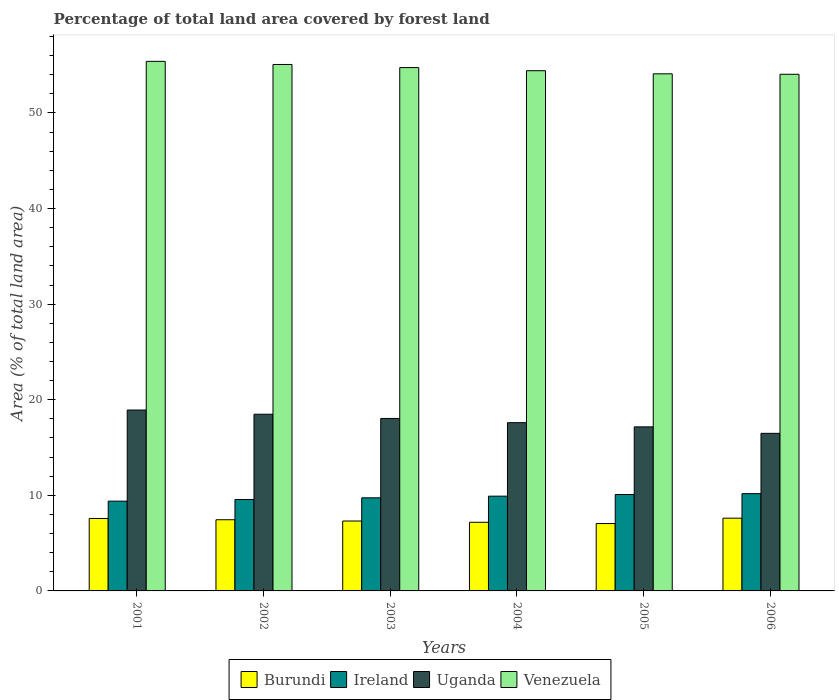Are the number of bars per tick equal to the number of legend labels?
Give a very brief answer. Yes. What is the label of the 5th group of bars from the left?
Ensure brevity in your answer.  2005. In how many cases, is the number of bars for a given year not equal to the number of legend labels?
Your answer should be compact. 0. What is the percentage of forest land in Burundi in 2003?
Ensure brevity in your answer.  7.31. Across all years, what is the maximum percentage of forest land in Venezuela?
Provide a short and direct response. 55.4. Across all years, what is the minimum percentage of forest land in Ireland?
Offer a terse response. 9.39. In which year was the percentage of forest land in Venezuela maximum?
Make the answer very short. 2001. In which year was the percentage of forest land in Venezuela minimum?
Your response must be concise. 2006. What is the total percentage of forest land in Ireland in the graph?
Your answer should be compact. 58.87. What is the difference between the percentage of forest land in Burundi in 2005 and that in 2006?
Your response must be concise. -0.56. What is the difference between the percentage of forest land in Ireland in 2003 and the percentage of forest land in Uganda in 2002?
Make the answer very short. -8.74. What is the average percentage of forest land in Burundi per year?
Offer a very short reply. 7.36. In the year 2001, what is the difference between the percentage of forest land in Venezuela and percentage of forest land in Ireland?
Your response must be concise. 46.01. What is the ratio of the percentage of forest land in Ireland in 2001 to that in 2002?
Provide a short and direct response. 0.98. What is the difference between the highest and the second highest percentage of forest land in Ireland?
Provide a short and direct response. 0.09. What is the difference between the highest and the lowest percentage of forest land in Uganda?
Provide a succinct answer. 2.44. In how many years, is the percentage of forest land in Burundi greater than the average percentage of forest land in Burundi taken over all years?
Offer a very short reply. 3. Is the sum of the percentage of forest land in Uganda in 2001 and 2002 greater than the maximum percentage of forest land in Burundi across all years?
Provide a succinct answer. Yes. What does the 4th bar from the left in 2006 represents?
Your answer should be very brief. Venezuela. What does the 4th bar from the right in 2005 represents?
Give a very brief answer. Burundi. Are all the bars in the graph horizontal?
Make the answer very short. No. Does the graph contain any zero values?
Provide a short and direct response. No. Does the graph contain grids?
Keep it short and to the point. No. Where does the legend appear in the graph?
Ensure brevity in your answer.  Bottom center. How are the legend labels stacked?
Ensure brevity in your answer.  Horizontal. What is the title of the graph?
Make the answer very short. Percentage of total land area covered by forest land. What is the label or title of the Y-axis?
Offer a terse response. Area (% of total land area). What is the Area (% of total land area) in Burundi in 2001?
Your response must be concise. 7.58. What is the Area (% of total land area) in Ireland in 2001?
Provide a short and direct response. 9.39. What is the Area (% of total land area) of Uganda in 2001?
Provide a succinct answer. 18.92. What is the Area (% of total land area) of Venezuela in 2001?
Give a very brief answer. 55.4. What is the Area (% of total land area) of Burundi in 2002?
Your response must be concise. 7.45. What is the Area (% of total land area) of Ireland in 2002?
Ensure brevity in your answer.  9.56. What is the Area (% of total land area) of Uganda in 2002?
Offer a terse response. 18.48. What is the Area (% of total land area) of Venezuela in 2002?
Offer a very short reply. 55.07. What is the Area (% of total land area) in Burundi in 2003?
Offer a terse response. 7.31. What is the Area (% of total land area) in Ireland in 2003?
Provide a succinct answer. 9.74. What is the Area (% of total land area) of Uganda in 2003?
Your response must be concise. 18.04. What is the Area (% of total land area) of Venezuela in 2003?
Provide a short and direct response. 54.75. What is the Area (% of total land area) of Burundi in 2004?
Your answer should be very brief. 7.18. What is the Area (% of total land area) of Ireland in 2004?
Offer a very short reply. 9.91. What is the Area (% of total land area) in Uganda in 2004?
Your response must be concise. 17.6. What is the Area (% of total land area) in Venezuela in 2004?
Offer a very short reply. 54.42. What is the Area (% of total land area) in Burundi in 2005?
Your response must be concise. 7.05. What is the Area (% of total land area) in Ireland in 2005?
Provide a short and direct response. 10.09. What is the Area (% of total land area) in Uganda in 2005?
Your answer should be compact. 17.16. What is the Area (% of total land area) of Venezuela in 2005?
Give a very brief answer. 54.09. What is the Area (% of total land area) in Burundi in 2006?
Offer a terse response. 7.61. What is the Area (% of total land area) of Ireland in 2006?
Give a very brief answer. 10.18. What is the Area (% of total land area) in Uganda in 2006?
Ensure brevity in your answer.  16.48. What is the Area (% of total land area) in Venezuela in 2006?
Provide a short and direct response. 54.05. Across all years, what is the maximum Area (% of total land area) of Burundi?
Keep it short and to the point. 7.61. Across all years, what is the maximum Area (% of total land area) of Ireland?
Offer a very short reply. 10.18. Across all years, what is the maximum Area (% of total land area) of Uganda?
Offer a terse response. 18.92. Across all years, what is the maximum Area (% of total land area) of Venezuela?
Provide a succinct answer. 55.4. Across all years, what is the minimum Area (% of total land area) of Burundi?
Provide a short and direct response. 7.05. Across all years, what is the minimum Area (% of total land area) in Ireland?
Keep it short and to the point. 9.39. Across all years, what is the minimum Area (% of total land area) of Uganda?
Provide a succinct answer. 16.48. Across all years, what is the minimum Area (% of total land area) of Venezuela?
Offer a terse response. 54.05. What is the total Area (% of total land area) in Burundi in the graph?
Your answer should be very brief. 44.17. What is the total Area (% of total land area) in Ireland in the graph?
Offer a terse response. 58.87. What is the total Area (% of total land area) in Uganda in the graph?
Make the answer very short. 106.7. What is the total Area (% of total land area) of Venezuela in the graph?
Make the answer very short. 327.77. What is the difference between the Area (% of total land area) in Burundi in 2001 and that in 2002?
Give a very brief answer. 0.13. What is the difference between the Area (% of total land area) of Ireland in 2001 and that in 2002?
Offer a very short reply. -0.17. What is the difference between the Area (% of total land area) of Uganda in 2001 and that in 2002?
Your answer should be compact. 0.44. What is the difference between the Area (% of total land area) of Venezuela in 2001 and that in 2002?
Ensure brevity in your answer.  0.33. What is the difference between the Area (% of total land area) in Burundi in 2001 and that in 2003?
Your answer should be very brief. 0.26. What is the difference between the Area (% of total land area) of Ireland in 2001 and that in 2003?
Provide a succinct answer. -0.35. What is the difference between the Area (% of total land area) of Uganda in 2001 and that in 2003?
Offer a terse response. 0.88. What is the difference between the Area (% of total land area) in Venezuela in 2001 and that in 2003?
Offer a very short reply. 0.65. What is the difference between the Area (% of total land area) of Burundi in 2001 and that in 2004?
Make the answer very short. 0.4. What is the difference between the Area (% of total land area) of Ireland in 2001 and that in 2004?
Provide a succinct answer. -0.52. What is the difference between the Area (% of total land area) in Uganda in 2001 and that in 2004?
Make the answer very short. 1.32. What is the difference between the Area (% of total land area) of Venezuela in 2001 and that in 2004?
Your response must be concise. 0.98. What is the difference between the Area (% of total land area) in Burundi in 2001 and that in 2005?
Make the answer very short. 0.53. What is the difference between the Area (% of total land area) in Ireland in 2001 and that in 2005?
Give a very brief answer. -0.7. What is the difference between the Area (% of total land area) in Uganda in 2001 and that in 2005?
Make the answer very short. 1.76. What is the difference between the Area (% of total land area) in Venezuela in 2001 and that in 2005?
Provide a succinct answer. 1.3. What is the difference between the Area (% of total land area) of Burundi in 2001 and that in 2006?
Offer a terse response. -0.03. What is the difference between the Area (% of total land area) in Ireland in 2001 and that in 2006?
Keep it short and to the point. -0.78. What is the difference between the Area (% of total land area) in Uganda in 2001 and that in 2006?
Make the answer very short. 2.44. What is the difference between the Area (% of total land area) in Venezuela in 2001 and that in 2006?
Give a very brief answer. 1.35. What is the difference between the Area (% of total land area) of Burundi in 2002 and that in 2003?
Keep it short and to the point. 0.13. What is the difference between the Area (% of total land area) in Ireland in 2002 and that in 2003?
Give a very brief answer. -0.17. What is the difference between the Area (% of total land area) in Uganda in 2002 and that in 2003?
Your response must be concise. 0.44. What is the difference between the Area (% of total land area) of Venezuela in 2002 and that in 2003?
Give a very brief answer. 0.33. What is the difference between the Area (% of total land area) of Burundi in 2002 and that in 2004?
Provide a succinct answer. 0.26. What is the difference between the Area (% of total land area) in Ireland in 2002 and that in 2004?
Ensure brevity in your answer.  -0.35. What is the difference between the Area (% of total land area) of Uganda in 2002 and that in 2004?
Ensure brevity in your answer.  0.88. What is the difference between the Area (% of total land area) in Venezuela in 2002 and that in 2004?
Provide a succinct answer. 0.65. What is the difference between the Area (% of total land area) of Burundi in 2002 and that in 2005?
Your answer should be very brief. 0.4. What is the difference between the Area (% of total land area) of Ireland in 2002 and that in 2005?
Offer a very short reply. -0.52. What is the difference between the Area (% of total land area) of Uganda in 2002 and that in 2005?
Ensure brevity in your answer.  1.32. What is the difference between the Area (% of total land area) of Venezuela in 2002 and that in 2005?
Provide a short and direct response. 0.98. What is the difference between the Area (% of total land area) in Burundi in 2002 and that in 2006?
Ensure brevity in your answer.  -0.16. What is the difference between the Area (% of total land area) in Ireland in 2002 and that in 2006?
Provide a succinct answer. -0.61. What is the difference between the Area (% of total land area) in Uganda in 2002 and that in 2006?
Your answer should be very brief. 2. What is the difference between the Area (% of total land area) in Venezuela in 2002 and that in 2006?
Make the answer very short. 1.03. What is the difference between the Area (% of total land area) of Burundi in 2003 and that in 2004?
Provide a succinct answer. 0.13. What is the difference between the Area (% of total land area) of Ireland in 2003 and that in 2004?
Offer a very short reply. -0.17. What is the difference between the Area (% of total land area) of Uganda in 2003 and that in 2004?
Offer a terse response. 0.44. What is the difference between the Area (% of total land area) of Venezuela in 2003 and that in 2004?
Provide a succinct answer. 0.33. What is the difference between the Area (% of total land area) of Burundi in 2003 and that in 2005?
Offer a very short reply. 0.26. What is the difference between the Area (% of total land area) of Ireland in 2003 and that in 2005?
Your answer should be compact. -0.35. What is the difference between the Area (% of total land area) in Uganda in 2003 and that in 2005?
Offer a very short reply. 0.88. What is the difference between the Area (% of total land area) of Venezuela in 2003 and that in 2005?
Offer a terse response. 0.65. What is the difference between the Area (% of total land area) in Burundi in 2003 and that in 2006?
Ensure brevity in your answer.  -0.3. What is the difference between the Area (% of total land area) in Ireland in 2003 and that in 2006?
Offer a very short reply. -0.44. What is the difference between the Area (% of total land area) of Uganda in 2003 and that in 2006?
Provide a short and direct response. 1.56. What is the difference between the Area (% of total land area) in Venezuela in 2003 and that in 2006?
Keep it short and to the point. 0.7. What is the difference between the Area (% of total land area) of Burundi in 2004 and that in 2005?
Provide a short and direct response. 0.13. What is the difference between the Area (% of total land area) in Ireland in 2004 and that in 2005?
Provide a short and direct response. -0.17. What is the difference between the Area (% of total land area) of Uganda in 2004 and that in 2005?
Keep it short and to the point. 0.44. What is the difference between the Area (% of total land area) of Venezuela in 2004 and that in 2005?
Make the answer very short. 0.33. What is the difference between the Area (% of total land area) of Burundi in 2004 and that in 2006?
Your answer should be compact. -0.43. What is the difference between the Area (% of total land area) of Ireland in 2004 and that in 2006?
Make the answer very short. -0.26. What is the difference between the Area (% of total land area) of Uganda in 2004 and that in 2006?
Make the answer very short. 1.12. What is the difference between the Area (% of total land area) in Venezuela in 2004 and that in 2006?
Offer a very short reply. 0.37. What is the difference between the Area (% of total land area) in Burundi in 2005 and that in 2006?
Make the answer very short. -0.56. What is the difference between the Area (% of total land area) of Ireland in 2005 and that in 2006?
Provide a short and direct response. -0.09. What is the difference between the Area (% of total land area) in Uganda in 2005 and that in 2006?
Your answer should be compact. 0.68. What is the difference between the Area (% of total land area) in Venezuela in 2005 and that in 2006?
Offer a very short reply. 0.05. What is the difference between the Area (% of total land area) in Burundi in 2001 and the Area (% of total land area) in Ireland in 2002?
Make the answer very short. -1.99. What is the difference between the Area (% of total land area) in Burundi in 2001 and the Area (% of total land area) in Uganda in 2002?
Provide a succinct answer. -10.9. What is the difference between the Area (% of total land area) in Burundi in 2001 and the Area (% of total land area) in Venezuela in 2002?
Offer a terse response. -47.49. What is the difference between the Area (% of total land area) of Ireland in 2001 and the Area (% of total land area) of Uganda in 2002?
Your answer should be compact. -9.09. What is the difference between the Area (% of total land area) of Ireland in 2001 and the Area (% of total land area) of Venezuela in 2002?
Provide a short and direct response. -45.68. What is the difference between the Area (% of total land area) in Uganda in 2001 and the Area (% of total land area) in Venezuela in 2002?
Offer a very short reply. -36.15. What is the difference between the Area (% of total land area) of Burundi in 2001 and the Area (% of total land area) of Ireland in 2003?
Ensure brevity in your answer.  -2.16. What is the difference between the Area (% of total land area) in Burundi in 2001 and the Area (% of total land area) in Uganda in 2003?
Give a very brief answer. -10.46. What is the difference between the Area (% of total land area) in Burundi in 2001 and the Area (% of total land area) in Venezuela in 2003?
Make the answer very short. -47.17. What is the difference between the Area (% of total land area) in Ireland in 2001 and the Area (% of total land area) in Uganda in 2003?
Give a very brief answer. -8.65. What is the difference between the Area (% of total land area) in Ireland in 2001 and the Area (% of total land area) in Venezuela in 2003?
Ensure brevity in your answer.  -45.35. What is the difference between the Area (% of total land area) in Uganda in 2001 and the Area (% of total land area) in Venezuela in 2003?
Provide a succinct answer. -35.82. What is the difference between the Area (% of total land area) in Burundi in 2001 and the Area (% of total land area) in Ireland in 2004?
Your answer should be very brief. -2.33. What is the difference between the Area (% of total land area) in Burundi in 2001 and the Area (% of total land area) in Uganda in 2004?
Make the answer very short. -10.02. What is the difference between the Area (% of total land area) in Burundi in 2001 and the Area (% of total land area) in Venezuela in 2004?
Make the answer very short. -46.84. What is the difference between the Area (% of total land area) of Ireland in 2001 and the Area (% of total land area) of Uganda in 2004?
Keep it short and to the point. -8.21. What is the difference between the Area (% of total land area) in Ireland in 2001 and the Area (% of total land area) in Venezuela in 2004?
Give a very brief answer. -45.03. What is the difference between the Area (% of total land area) of Uganda in 2001 and the Area (% of total land area) of Venezuela in 2004?
Your answer should be very brief. -35.5. What is the difference between the Area (% of total land area) of Burundi in 2001 and the Area (% of total land area) of Ireland in 2005?
Provide a short and direct response. -2.51. What is the difference between the Area (% of total land area) in Burundi in 2001 and the Area (% of total land area) in Uganda in 2005?
Give a very brief answer. -9.58. What is the difference between the Area (% of total land area) of Burundi in 2001 and the Area (% of total land area) of Venezuela in 2005?
Your answer should be compact. -46.52. What is the difference between the Area (% of total land area) in Ireland in 2001 and the Area (% of total land area) in Uganda in 2005?
Your answer should be compact. -7.77. What is the difference between the Area (% of total land area) of Ireland in 2001 and the Area (% of total land area) of Venezuela in 2005?
Your response must be concise. -44.7. What is the difference between the Area (% of total land area) in Uganda in 2001 and the Area (% of total land area) in Venezuela in 2005?
Offer a terse response. -35.17. What is the difference between the Area (% of total land area) in Burundi in 2001 and the Area (% of total land area) in Ireland in 2006?
Offer a very short reply. -2.6. What is the difference between the Area (% of total land area) in Burundi in 2001 and the Area (% of total land area) in Uganda in 2006?
Offer a very short reply. -8.91. What is the difference between the Area (% of total land area) of Burundi in 2001 and the Area (% of total land area) of Venezuela in 2006?
Your answer should be compact. -46.47. What is the difference between the Area (% of total land area) in Ireland in 2001 and the Area (% of total land area) in Uganda in 2006?
Offer a terse response. -7.09. What is the difference between the Area (% of total land area) of Ireland in 2001 and the Area (% of total land area) of Venezuela in 2006?
Your answer should be very brief. -44.66. What is the difference between the Area (% of total land area) of Uganda in 2001 and the Area (% of total land area) of Venezuela in 2006?
Provide a succinct answer. -35.12. What is the difference between the Area (% of total land area) in Burundi in 2002 and the Area (% of total land area) in Ireland in 2003?
Your answer should be compact. -2.29. What is the difference between the Area (% of total land area) of Burundi in 2002 and the Area (% of total land area) of Uganda in 2003?
Your answer should be compact. -10.6. What is the difference between the Area (% of total land area) in Burundi in 2002 and the Area (% of total land area) in Venezuela in 2003?
Your answer should be very brief. -47.3. What is the difference between the Area (% of total land area) of Ireland in 2002 and the Area (% of total land area) of Uganda in 2003?
Give a very brief answer. -8.48. What is the difference between the Area (% of total land area) in Ireland in 2002 and the Area (% of total land area) in Venezuela in 2003?
Offer a very short reply. -45.18. What is the difference between the Area (% of total land area) of Uganda in 2002 and the Area (% of total land area) of Venezuela in 2003?
Provide a succinct answer. -36.26. What is the difference between the Area (% of total land area) in Burundi in 2002 and the Area (% of total land area) in Ireland in 2004?
Your response must be concise. -2.47. What is the difference between the Area (% of total land area) in Burundi in 2002 and the Area (% of total land area) in Uganda in 2004?
Your answer should be compact. -10.16. What is the difference between the Area (% of total land area) in Burundi in 2002 and the Area (% of total land area) in Venezuela in 2004?
Offer a very short reply. -46.97. What is the difference between the Area (% of total land area) in Ireland in 2002 and the Area (% of total land area) in Uganda in 2004?
Offer a terse response. -8.04. What is the difference between the Area (% of total land area) of Ireland in 2002 and the Area (% of total land area) of Venezuela in 2004?
Offer a terse response. -44.85. What is the difference between the Area (% of total land area) in Uganda in 2002 and the Area (% of total land area) in Venezuela in 2004?
Offer a terse response. -35.94. What is the difference between the Area (% of total land area) of Burundi in 2002 and the Area (% of total land area) of Ireland in 2005?
Make the answer very short. -2.64. What is the difference between the Area (% of total land area) in Burundi in 2002 and the Area (% of total land area) in Uganda in 2005?
Offer a very short reply. -9.72. What is the difference between the Area (% of total land area) in Burundi in 2002 and the Area (% of total land area) in Venezuela in 2005?
Keep it short and to the point. -46.65. What is the difference between the Area (% of total land area) in Ireland in 2002 and the Area (% of total land area) in Uganda in 2005?
Offer a very short reply. -7.6. What is the difference between the Area (% of total land area) in Ireland in 2002 and the Area (% of total land area) in Venezuela in 2005?
Give a very brief answer. -44.53. What is the difference between the Area (% of total land area) of Uganda in 2002 and the Area (% of total land area) of Venezuela in 2005?
Give a very brief answer. -35.61. What is the difference between the Area (% of total land area) of Burundi in 2002 and the Area (% of total land area) of Ireland in 2006?
Keep it short and to the point. -2.73. What is the difference between the Area (% of total land area) in Burundi in 2002 and the Area (% of total land area) in Uganda in 2006?
Give a very brief answer. -9.04. What is the difference between the Area (% of total land area) of Burundi in 2002 and the Area (% of total land area) of Venezuela in 2006?
Your answer should be compact. -46.6. What is the difference between the Area (% of total land area) of Ireland in 2002 and the Area (% of total land area) of Uganda in 2006?
Offer a very short reply. -6.92. What is the difference between the Area (% of total land area) of Ireland in 2002 and the Area (% of total land area) of Venezuela in 2006?
Offer a very short reply. -44.48. What is the difference between the Area (% of total land area) of Uganda in 2002 and the Area (% of total land area) of Venezuela in 2006?
Your response must be concise. -35.56. What is the difference between the Area (% of total land area) of Burundi in 2003 and the Area (% of total land area) of Ireland in 2004?
Offer a very short reply. -2.6. What is the difference between the Area (% of total land area) in Burundi in 2003 and the Area (% of total land area) in Uganda in 2004?
Ensure brevity in your answer.  -10.29. What is the difference between the Area (% of total land area) of Burundi in 2003 and the Area (% of total land area) of Venezuela in 2004?
Provide a short and direct response. -47.11. What is the difference between the Area (% of total land area) of Ireland in 2003 and the Area (% of total land area) of Uganda in 2004?
Your response must be concise. -7.86. What is the difference between the Area (% of total land area) of Ireland in 2003 and the Area (% of total land area) of Venezuela in 2004?
Ensure brevity in your answer.  -44.68. What is the difference between the Area (% of total land area) of Uganda in 2003 and the Area (% of total land area) of Venezuela in 2004?
Keep it short and to the point. -36.38. What is the difference between the Area (% of total land area) in Burundi in 2003 and the Area (% of total land area) in Ireland in 2005?
Offer a terse response. -2.77. What is the difference between the Area (% of total land area) in Burundi in 2003 and the Area (% of total land area) in Uganda in 2005?
Keep it short and to the point. -9.85. What is the difference between the Area (% of total land area) of Burundi in 2003 and the Area (% of total land area) of Venezuela in 2005?
Ensure brevity in your answer.  -46.78. What is the difference between the Area (% of total land area) in Ireland in 2003 and the Area (% of total land area) in Uganda in 2005?
Your answer should be compact. -7.42. What is the difference between the Area (% of total land area) in Ireland in 2003 and the Area (% of total land area) in Venezuela in 2005?
Give a very brief answer. -44.35. What is the difference between the Area (% of total land area) in Uganda in 2003 and the Area (% of total land area) in Venezuela in 2005?
Offer a terse response. -36.05. What is the difference between the Area (% of total land area) of Burundi in 2003 and the Area (% of total land area) of Ireland in 2006?
Ensure brevity in your answer.  -2.86. What is the difference between the Area (% of total land area) in Burundi in 2003 and the Area (% of total land area) in Uganda in 2006?
Your response must be concise. -9.17. What is the difference between the Area (% of total land area) of Burundi in 2003 and the Area (% of total land area) of Venezuela in 2006?
Provide a short and direct response. -46.73. What is the difference between the Area (% of total land area) of Ireland in 2003 and the Area (% of total land area) of Uganda in 2006?
Keep it short and to the point. -6.75. What is the difference between the Area (% of total land area) of Ireland in 2003 and the Area (% of total land area) of Venezuela in 2006?
Your response must be concise. -44.31. What is the difference between the Area (% of total land area) of Uganda in 2003 and the Area (% of total land area) of Venezuela in 2006?
Offer a terse response. -36. What is the difference between the Area (% of total land area) of Burundi in 2004 and the Area (% of total land area) of Ireland in 2005?
Give a very brief answer. -2.91. What is the difference between the Area (% of total land area) of Burundi in 2004 and the Area (% of total land area) of Uganda in 2005?
Give a very brief answer. -9.98. What is the difference between the Area (% of total land area) of Burundi in 2004 and the Area (% of total land area) of Venezuela in 2005?
Give a very brief answer. -46.91. What is the difference between the Area (% of total land area) of Ireland in 2004 and the Area (% of total land area) of Uganda in 2005?
Keep it short and to the point. -7.25. What is the difference between the Area (% of total land area) of Ireland in 2004 and the Area (% of total land area) of Venezuela in 2005?
Provide a succinct answer. -44.18. What is the difference between the Area (% of total land area) of Uganda in 2004 and the Area (% of total land area) of Venezuela in 2005?
Provide a succinct answer. -36.49. What is the difference between the Area (% of total land area) of Burundi in 2004 and the Area (% of total land area) of Ireland in 2006?
Offer a very short reply. -3. What is the difference between the Area (% of total land area) in Burundi in 2004 and the Area (% of total land area) in Uganda in 2006?
Offer a very short reply. -9.3. What is the difference between the Area (% of total land area) in Burundi in 2004 and the Area (% of total land area) in Venezuela in 2006?
Provide a succinct answer. -46.87. What is the difference between the Area (% of total land area) of Ireland in 2004 and the Area (% of total land area) of Uganda in 2006?
Give a very brief answer. -6.57. What is the difference between the Area (% of total land area) in Ireland in 2004 and the Area (% of total land area) in Venezuela in 2006?
Provide a short and direct response. -44.13. What is the difference between the Area (% of total land area) in Uganda in 2004 and the Area (% of total land area) in Venezuela in 2006?
Your answer should be compact. -36.44. What is the difference between the Area (% of total land area) in Burundi in 2005 and the Area (% of total land area) in Ireland in 2006?
Your answer should be compact. -3.13. What is the difference between the Area (% of total land area) of Burundi in 2005 and the Area (% of total land area) of Uganda in 2006?
Ensure brevity in your answer.  -9.44. What is the difference between the Area (% of total land area) of Burundi in 2005 and the Area (% of total land area) of Venezuela in 2006?
Ensure brevity in your answer.  -47. What is the difference between the Area (% of total land area) in Ireland in 2005 and the Area (% of total land area) in Uganda in 2006?
Ensure brevity in your answer.  -6.4. What is the difference between the Area (% of total land area) in Ireland in 2005 and the Area (% of total land area) in Venezuela in 2006?
Offer a very short reply. -43.96. What is the difference between the Area (% of total land area) of Uganda in 2005 and the Area (% of total land area) of Venezuela in 2006?
Provide a short and direct response. -36.88. What is the average Area (% of total land area) in Burundi per year?
Give a very brief answer. 7.36. What is the average Area (% of total land area) of Ireland per year?
Your answer should be very brief. 9.81. What is the average Area (% of total land area) in Uganda per year?
Keep it short and to the point. 17.78. What is the average Area (% of total land area) of Venezuela per year?
Keep it short and to the point. 54.63. In the year 2001, what is the difference between the Area (% of total land area) of Burundi and Area (% of total land area) of Ireland?
Provide a succinct answer. -1.81. In the year 2001, what is the difference between the Area (% of total land area) of Burundi and Area (% of total land area) of Uganda?
Give a very brief answer. -11.35. In the year 2001, what is the difference between the Area (% of total land area) of Burundi and Area (% of total land area) of Venezuela?
Your response must be concise. -47.82. In the year 2001, what is the difference between the Area (% of total land area) of Ireland and Area (% of total land area) of Uganda?
Provide a succinct answer. -9.53. In the year 2001, what is the difference between the Area (% of total land area) of Ireland and Area (% of total land area) of Venezuela?
Your response must be concise. -46.01. In the year 2001, what is the difference between the Area (% of total land area) of Uganda and Area (% of total land area) of Venezuela?
Offer a very short reply. -36.47. In the year 2002, what is the difference between the Area (% of total land area) of Burundi and Area (% of total land area) of Ireland?
Offer a very short reply. -2.12. In the year 2002, what is the difference between the Area (% of total land area) of Burundi and Area (% of total land area) of Uganda?
Provide a short and direct response. -11.04. In the year 2002, what is the difference between the Area (% of total land area) of Burundi and Area (% of total land area) of Venezuela?
Keep it short and to the point. -47.63. In the year 2002, what is the difference between the Area (% of total land area) of Ireland and Area (% of total land area) of Uganda?
Keep it short and to the point. -8.92. In the year 2002, what is the difference between the Area (% of total land area) of Ireland and Area (% of total land area) of Venezuela?
Your answer should be very brief. -45.51. In the year 2002, what is the difference between the Area (% of total land area) of Uganda and Area (% of total land area) of Venezuela?
Provide a short and direct response. -36.59. In the year 2003, what is the difference between the Area (% of total land area) of Burundi and Area (% of total land area) of Ireland?
Ensure brevity in your answer.  -2.43. In the year 2003, what is the difference between the Area (% of total land area) in Burundi and Area (% of total land area) in Uganda?
Give a very brief answer. -10.73. In the year 2003, what is the difference between the Area (% of total land area) of Burundi and Area (% of total land area) of Venezuela?
Make the answer very short. -47.43. In the year 2003, what is the difference between the Area (% of total land area) of Ireland and Area (% of total land area) of Uganda?
Your answer should be compact. -8.3. In the year 2003, what is the difference between the Area (% of total land area) of Ireland and Area (% of total land area) of Venezuela?
Offer a terse response. -45.01. In the year 2003, what is the difference between the Area (% of total land area) in Uganda and Area (% of total land area) in Venezuela?
Your answer should be compact. -36.7. In the year 2004, what is the difference between the Area (% of total land area) in Burundi and Area (% of total land area) in Ireland?
Make the answer very short. -2.73. In the year 2004, what is the difference between the Area (% of total land area) in Burundi and Area (% of total land area) in Uganda?
Keep it short and to the point. -10.42. In the year 2004, what is the difference between the Area (% of total land area) of Burundi and Area (% of total land area) of Venezuela?
Keep it short and to the point. -47.24. In the year 2004, what is the difference between the Area (% of total land area) in Ireland and Area (% of total land area) in Uganda?
Provide a succinct answer. -7.69. In the year 2004, what is the difference between the Area (% of total land area) of Ireland and Area (% of total land area) of Venezuela?
Your answer should be very brief. -44.51. In the year 2004, what is the difference between the Area (% of total land area) of Uganda and Area (% of total land area) of Venezuela?
Provide a succinct answer. -36.82. In the year 2005, what is the difference between the Area (% of total land area) of Burundi and Area (% of total land area) of Ireland?
Give a very brief answer. -3.04. In the year 2005, what is the difference between the Area (% of total land area) in Burundi and Area (% of total land area) in Uganda?
Make the answer very short. -10.11. In the year 2005, what is the difference between the Area (% of total land area) of Burundi and Area (% of total land area) of Venezuela?
Give a very brief answer. -47.05. In the year 2005, what is the difference between the Area (% of total land area) of Ireland and Area (% of total land area) of Uganda?
Provide a succinct answer. -7.08. In the year 2005, what is the difference between the Area (% of total land area) of Ireland and Area (% of total land area) of Venezuela?
Make the answer very short. -44.01. In the year 2005, what is the difference between the Area (% of total land area) of Uganda and Area (% of total land area) of Venezuela?
Provide a succinct answer. -36.93. In the year 2006, what is the difference between the Area (% of total land area) in Burundi and Area (% of total land area) in Ireland?
Offer a terse response. -2.57. In the year 2006, what is the difference between the Area (% of total land area) in Burundi and Area (% of total land area) in Uganda?
Your response must be concise. -8.88. In the year 2006, what is the difference between the Area (% of total land area) of Burundi and Area (% of total land area) of Venezuela?
Offer a very short reply. -46.44. In the year 2006, what is the difference between the Area (% of total land area) in Ireland and Area (% of total land area) in Uganda?
Make the answer very short. -6.31. In the year 2006, what is the difference between the Area (% of total land area) in Ireland and Area (% of total land area) in Venezuela?
Keep it short and to the point. -43.87. In the year 2006, what is the difference between the Area (% of total land area) in Uganda and Area (% of total land area) in Venezuela?
Keep it short and to the point. -37.56. What is the ratio of the Area (% of total land area) of Burundi in 2001 to that in 2002?
Ensure brevity in your answer.  1.02. What is the ratio of the Area (% of total land area) in Ireland in 2001 to that in 2002?
Ensure brevity in your answer.  0.98. What is the ratio of the Area (% of total land area) in Uganda in 2001 to that in 2002?
Offer a very short reply. 1.02. What is the ratio of the Area (% of total land area) in Venezuela in 2001 to that in 2002?
Offer a terse response. 1.01. What is the ratio of the Area (% of total land area) in Burundi in 2001 to that in 2003?
Your answer should be compact. 1.04. What is the ratio of the Area (% of total land area) in Ireland in 2001 to that in 2003?
Offer a terse response. 0.96. What is the ratio of the Area (% of total land area) in Uganda in 2001 to that in 2003?
Provide a succinct answer. 1.05. What is the ratio of the Area (% of total land area) in Venezuela in 2001 to that in 2003?
Give a very brief answer. 1.01. What is the ratio of the Area (% of total land area) in Burundi in 2001 to that in 2004?
Your response must be concise. 1.06. What is the ratio of the Area (% of total land area) of Uganda in 2001 to that in 2004?
Your answer should be very brief. 1.08. What is the ratio of the Area (% of total land area) of Venezuela in 2001 to that in 2004?
Give a very brief answer. 1.02. What is the ratio of the Area (% of total land area) of Burundi in 2001 to that in 2005?
Your answer should be very brief. 1.08. What is the ratio of the Area (% of total land area) in Uganda in 2001 to that in 2005?
Provide a short and direct response. 1.1. What is the ratio of the Area (% of total land area) of Venezuela in 2001 to that in 2005?
Your response must be concise. 1.02. What is the ratio of the Area (% of total land area) in Ireland in 2001 to that in 2006?
Provide a short and direct response. 0.92. What is the ratio of the Area (% of total land area) of Uganda in 2001 to that in 2006?
Ensure brevity in your answer.  1.15. What is the ratio of the Area (% of total land area) of Burundi in 2002 to that in 2003?
Keep it short and to the point. 1.02. What is the ratio of the Area (% of total land area) of Ireland in 2002 to that in 2003?
Offer a very short reply. 0.98. What is the ratio of the Area (% of total land area) of Uganda in 2002 to that in 2003?
Give a very brief answer. 1.02. What is the ratio of the Area (% of total land area) of Burundi in 2002 to that in 2004?
Offer a terse response. 1.04. What is the ratio of the Area (% of total land area) in Ireland in 2002 to that in 2004?
Offer a terse response. 0.96. What is the ratio of the Area (% of total land area) of Venezuela in 2002 to that in 2004?
Offer a very short reply. 1.01. What is the ratio of the Area (% of total land area) in Burundi in 2002 to that in 2005?
Offer a terse response. 1.06. What is the ratio of the Area (% of total land area) of Ireland in 2002 to that in 2005?
Offer a terse response. 0.95. What is the ratio of the Area (% of total land area) in Uganda in 2002 to that in 2005?
Make the answer very short. 1.08. What is the ratio of the Area (% of total land area) in Venezuela in 2002 to that in 2005?
Your answer should be compact. 1.02. What is the ratio of the Area (% of total land area) in Burundi in 2002 to that in 2006?
Provide a succinct answer. 0.98. What is the ratio of the Area (% of total land area) of Ireland in 2002 to that in 2006?
Offer a very short reply. 0.94. What is the ratio of the Area (% of total land area) in Uganda in 2002 to that in 2006?
Give a very brief answer. 1.12. What is the ratio of the Area (% of total land area) of Venezuela in 2002 to that in 2006?
Ensure brevity in your answer.  1.02. What is the ratio of the Area (% of total land area) of Burundi in 2003 to that in 2004?
Your answer should be very brief. 1.02. What is the ratio of the Area (% of total land area) in Ireland in 2003 to that in 2004?
Ensure brevity in your answer.  0.98. What is the ratio of the Area (% of total land area) in Uganda in 2003 to that in 2004?
Your response must be concise. 1.02. What is the ratio of the Area (% of total land area) in Burundi in 2003 to that in 2005?
Provide a short and direct response. 1.04. What is the ratio of the Area (% of total land area) of Ireland in 2003 to that in 2005?
Offer a terse response. 0.97. What is the ratio of the Area (% of total land area) in Uganda in 2003 to that in 2005?
Ensure brevity in your answer.  1.05. What is the ratio of the Area (% of total land area) in Venezuela in 2003 to that in 2005?
Your answer should be compact. 1.01. What is the ratio of the Area (% of total land area) of Burundi in 2003 to that in 2006?
Make the answer very short. 0.96. What is the ratio of the Area (% of total land area) of Ireland in 2003 to that in 2006?
Keep it short and to the point. 0.96. What is the ratio of the Area (% of total land area) of Uganda in 2003 to that in 2006?
Make the answer very short. 1.09. What is the ratio of the Area (% of total land area) of Venezuela in 2003 to that in 2006?
Your answer should be compact. 1.01. What is the ratio of the Area (% of total land area) of Burundi in 2004 to that in 2005?
Offer a terse response. 1.02. What is the ratio of the Area (% of total land area) of Ireland in 2004 to that in 2005?
Your answer should be compact. 0.98. What is the ratio of the Area (% of total land area) of Uganda in 2004 to that in 2005?
Give a very brief answer. 1.03. What is the ratio of the Area (% of total land area) of Burundi in 2004 to that in 2006?
Provide a short and direct response. 0.94. What is the ratio of the Area (% of total land area) in Ireland in 2004 to that in 2006?
Your answer should be compact. 0.97. What is the ratio of the Area (% of total land area) of Uganda in 2004 to that in 2006?
Provide a short and direct response. 1.07. What is the ratio of the Area (% of total land area) of Venezuela in 2004 to that in 2006?
Your answer should be very brief. 1.01. What is the ratio of the Area (% of total land area) of Burundi in 2005 to that in 2006?
Provide a short and direct response. 0.93. What is the ratio of the Area (% of total land area) in Uganda in 2005 to that in 2006?
Offer a very short reply. 1.04. What is the difference between the highest and the second highest Area (% of total land area) in Burundi?
Ensure brevity in your answer.  0.03. What is the difference between the highest and the second highest Area (% of total land area) in Ireland?
Make the answer very short. 0.09. What is the difference between the highest and the second highest Area (% of total land area) in Uganda?
Your response must be concise. 0.44. What is the difference between the highest and the second highest Area (% of total land area) in Venezuela?
Keep it short and to the point. 0.33. What is the difference between the highest and the lowest Area (% of total land area) in Burundi?
Provide a short and direct response. 0.56. What is the difference between the highest and the lowest Area (% of total land area) of Ireland?
Make the answer very short. 0.78. What is the difference between the highest and the lowest Area (% of total land area) in Uganda?
Offer a terse response. 2.44. What is the difference between the highest and the lowest Area (% of total land area) in Venezuela?
Your response must be concise. 1.35. 